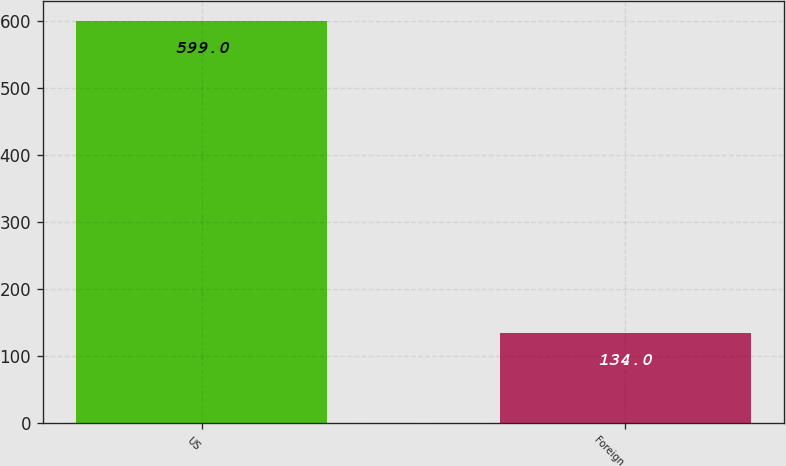Convert chart to OTSL. <chart><loc_0><loc_0><loc_500><loc_500><bar_chart><fcel>US<fcel>Foreign<nl><fcel>599<fcel>134<nl></chart> 